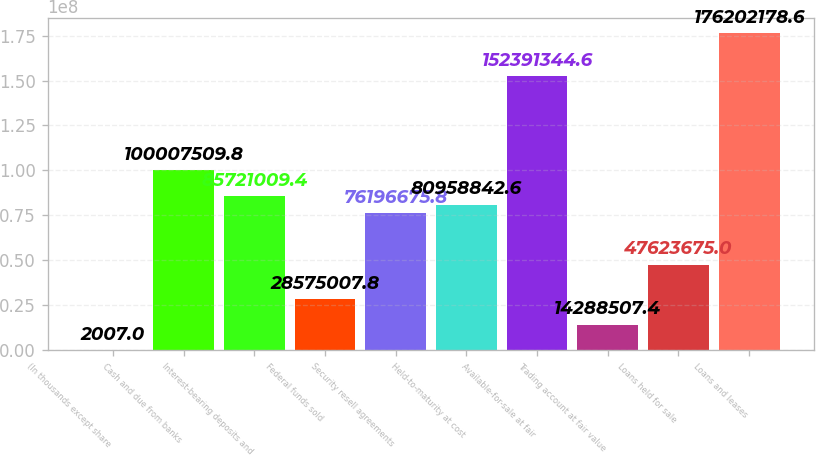<chart> <loc_0><loc_0><loc_500><loc_500><bar_chart><fcel>(In thousands except share<fcel>Cash and due from banks<fcel>Interest-bearing deposits and<fcel>Federal funds sold<fcel>Security resell agreements<fcel>Held-to-maturity at cost<fcel>Available-for-sale at fair<fcel>Trading account at fair value<fcel>Loans held for sale<fcel>Loans and leases<nl><fcel>2007<fcel>1.00008e+08<fcel>8.5721e+07<fcel>2.8575e+07<fcel>7.61967e+07<fcel>8.09588e+07<fcel>1.52391e+08<fcel>1.42885e+07<fcel>4.76237e+07<fcel>1.76202e+08<nl></chart> 